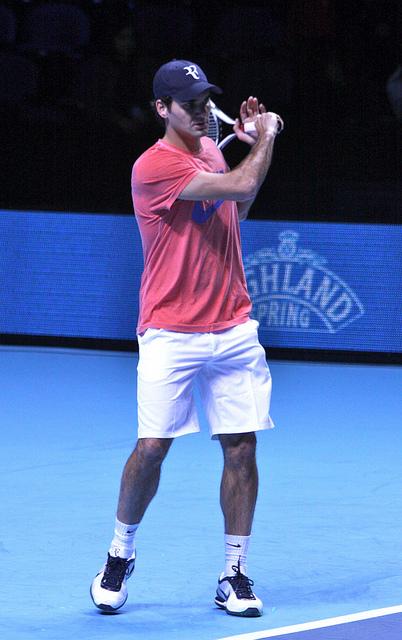Is the guy wearing long pants?
Keep it brief. No. Does the athlete likes the brand he wears?
Be succinct. Yes. Why are his pockets bulging out?
Concise answer only. Balls. Is this tennis match sponsored?
Keep it brief. Yes. 